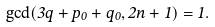<formula> <loc_0><loc_0><loc_500><loc_500>\gcd ( 3 q + p _ { 0 } + q _ { 0 } , 2 n + 1 ) = 1 .</formula> 